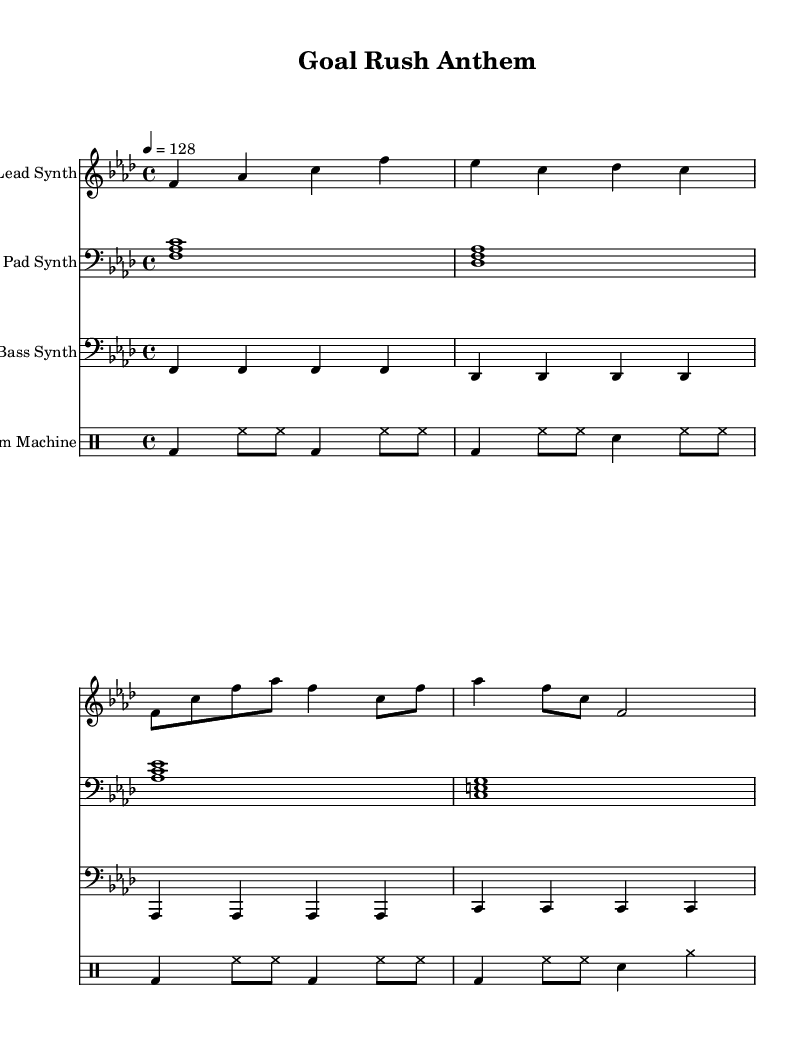What is the key signature of this music? The key signature is F minor, indicated by the presence of four flats (B♭, E♭, A♭, D♭).
Answer: F minor What is the time signature of this music? The time signature is 4/4, indicated at the beginning of the score. This means there are four beats in each measure, and the quarter note receives one beat.
Answer: 4/4 What is the tempo marking for this piece? The tempo marking is a quarter note equals 128 beats per minute, which is written as "4 = 128". This indicates the speed at which the piece should be played.
Answer: 128 How many measures are in the lead synth part? The lead synth part contains four measures of music notation, represented by four groups of notes separated by vertical lines in the score.
Answer: 4 Which instrument plays the drum pattern? The drum pattern is played by the "Drum Machine," which is indicated by the separate staff labeled accordingly in the score.
Answer: Drum Machine What type of synth is playing the lowest frequency part? The lowest frequency part is played by the "Bass Synth," which is indicated by the staff and the part named as such. The bass synth contributes to the lower harmonics of the overall sound.
Answer: Bass Synth What is the rhythmic pattern of the drum in the first measure? The rhythmic pattern in the first measure is characterized by a bass drum on beats one and three, and hi-hats playing on the off beats, creating a driving rhythm typical in electronic music.
Answer: Bass and hi-hat 